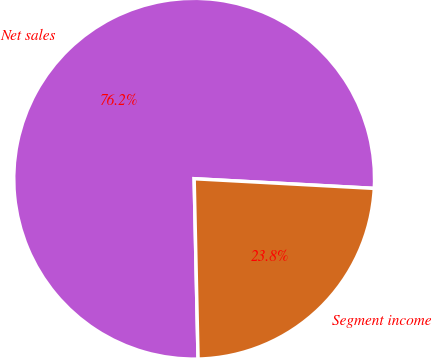<chart> <loc_0><loc_0><loc_500><loc_500><pie_chart><fcel>Net sales<fcel>Segment income<nl><fcel>76.2%<fcel>23.8%<nl></chart> 